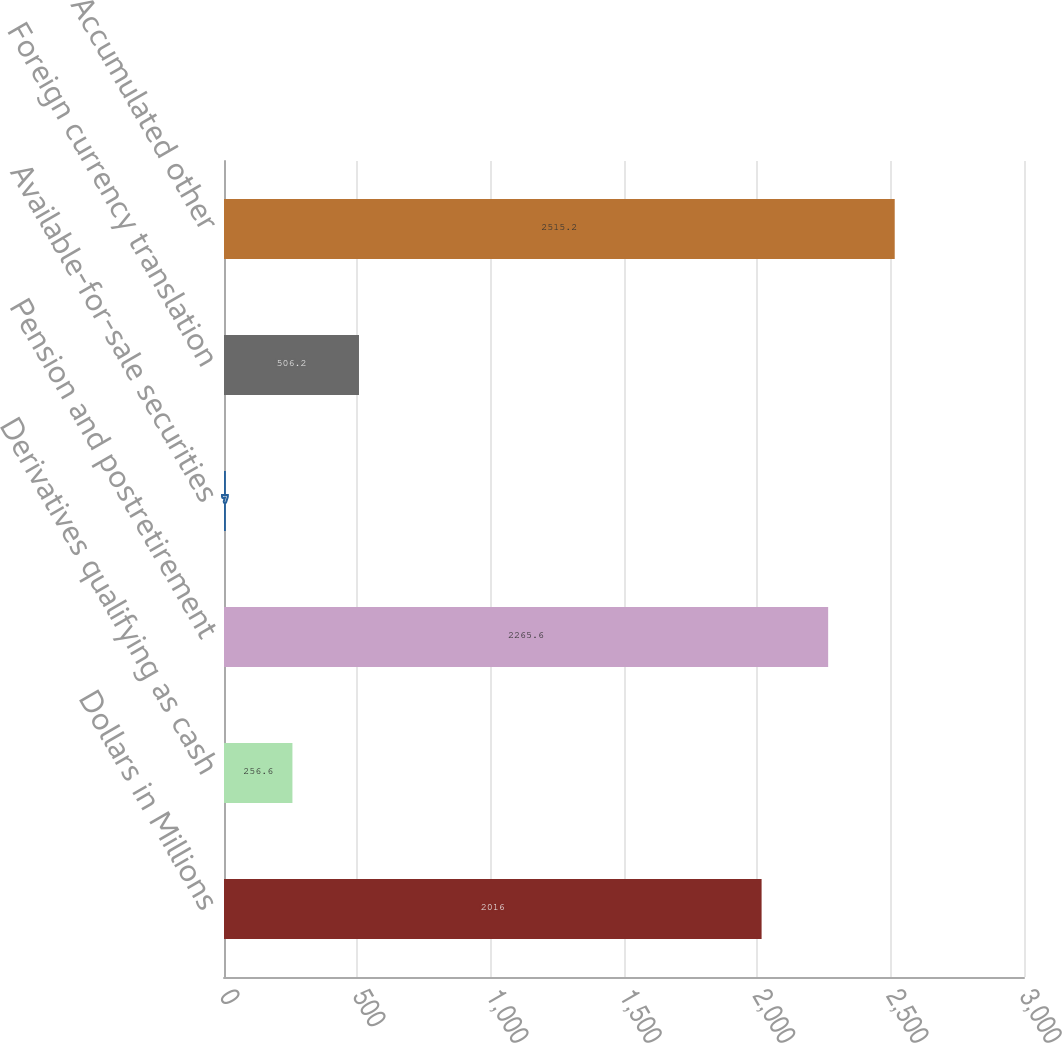<chart> <loc_0><loc_0><loc_500><loc_500><bar_chart><fcel>Dollars in Millions<fcel>Derivatives qualifying as cash<fcel>Pension and postretirement<fcel>Available-for-sale securities<fcel>Foreign currency translation<fcel>Accumulated other<nl><fcel>2016<fcel>256.6<fcel>2265.6<fcel>7<fcel>506.2<fcel>2515.2<nl></chart> 